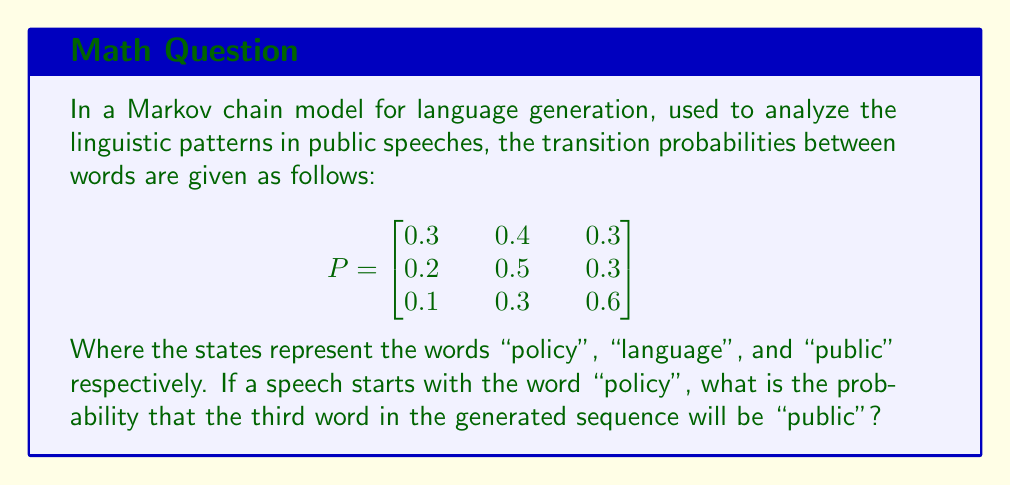Provide a solution to this math problem. To solve this problem, we need to use the properties of Markov chains and matrix multiplication. Let's approach this step-by-step:

1) The initial state vector is $v_0 = [1, 0, 0]$ since we start with "policy".

2) To find the probability distribution after two transitions, we need to multiply the initial state vector by the transition matrix twice:

   $v_2 = v_0 \cdot P^2$

3) Let's calculate $P^2$:

   $$
   P^2 = \begin{bmatrix}
   0.3 & 0.4 & 0.3 \\
   0.2 & 0.5 & 0.3 \\
   0.1 & 0.3 & 0.6
   \end{bmatrix} \cdot 
   \begin{bmatrix}
   0.3 & 0.4 & 0.3 \\
   0.2 & 0.5 & 0.3 \\
   0.1 & 0.3 & 0.6
   \end{bmatrix}
   $$

4) Performing the matrix multiplication:

   $$
   P^2 = \begin{bmatrix}
   0.21 & 0.43 & 0.36 \\
   0.19 & 0.44 & 0.37 \\
   0.13 & 0.36 & 0.51
   \end{bmatrix}
   $$

5) Now, we multiply $v_0$ by $P^2$:

   $v_2 = [1, 0, 0] \cdot \begin{bmatrix}
   0.21 & 0.43 & 0.36 \\
   0.19 & 0.44 & 0.37 \\
   0.13 & 0.36 & 0.51
   \end{bmatrix} = [0.21, 0.43, 0.36]$

6) The probability that the third word is "public" is the third element of this resulting vector.
Answer: 0.36 